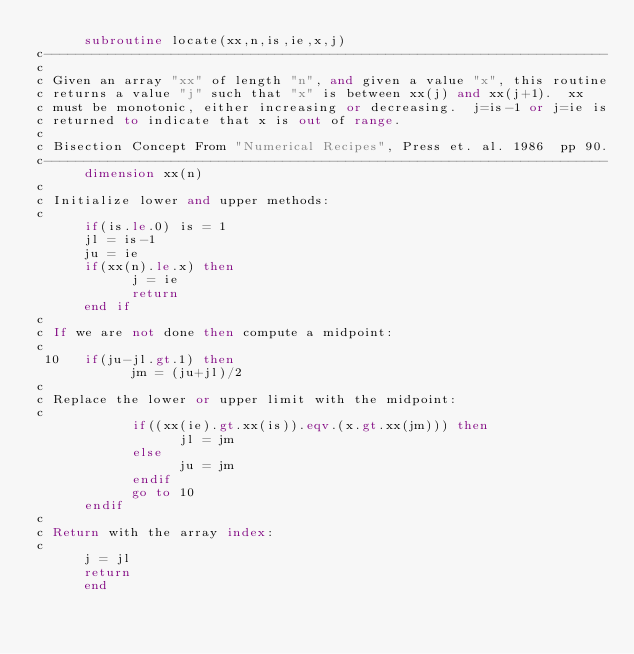<code> <loc_0><loc_0><loc_500><loc_500><_FORTRAN_>      subroutine locate(xx,n,is,ie,x,j)
c-----------------------------------------------------------------------
c
c Given an array "xx" of length "n", and given a value "x", this routine
c returns a value "j" such that "x" is between xx(j) and xx(j+1).  xx
c must be monotonic, either increasing or decreasing.  j=is-1 or j=ie is
c returned to indicate that x is out of range.
c
c Bisection Concept From "Numerical Recipes", Press et. al. 1986  pp 90.
c-----------------------------------------------------------------------
      dimension xx(n)
c
c Initialize lower and upper methods:
c
      if(is.le.0) is = 1
      jl = is-1
      ju = ie
      if(xx(n).le.x) then
            j = ie
            return
      end if
c
c If we are not done then compute a midpoint:
c
 10   if(ju-jl.gt.1) then
            jm = (ju+jl)/2
c
c Replace the lower or upper limit with the midpoint:
c
            if((xx(ie).gt.xx(is)).eqv.(x.gt.xx(jm))) then
                  jl = jm
            else
                  ju = jm
            endif
            go to 10
      endif
c
c Return with the array index:
c
      j = jl
      return
      end
</code> 